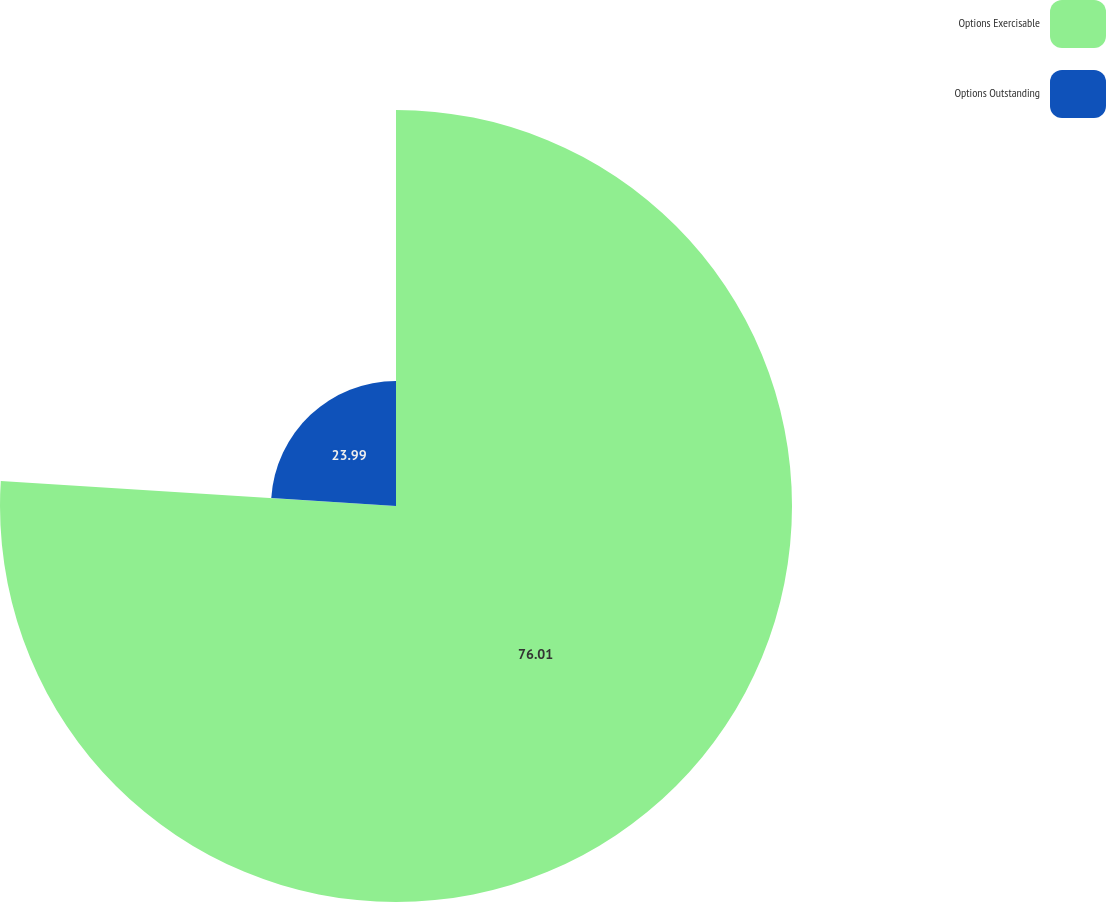Convert chart. <chart><loc_0><loc_0><loc_500><loc_500><pie_chart><fcel>Options Exercisable<fcel>Options Outstanding<nl><fcel>76.01%<fcel>23.99%<nl></chart> 